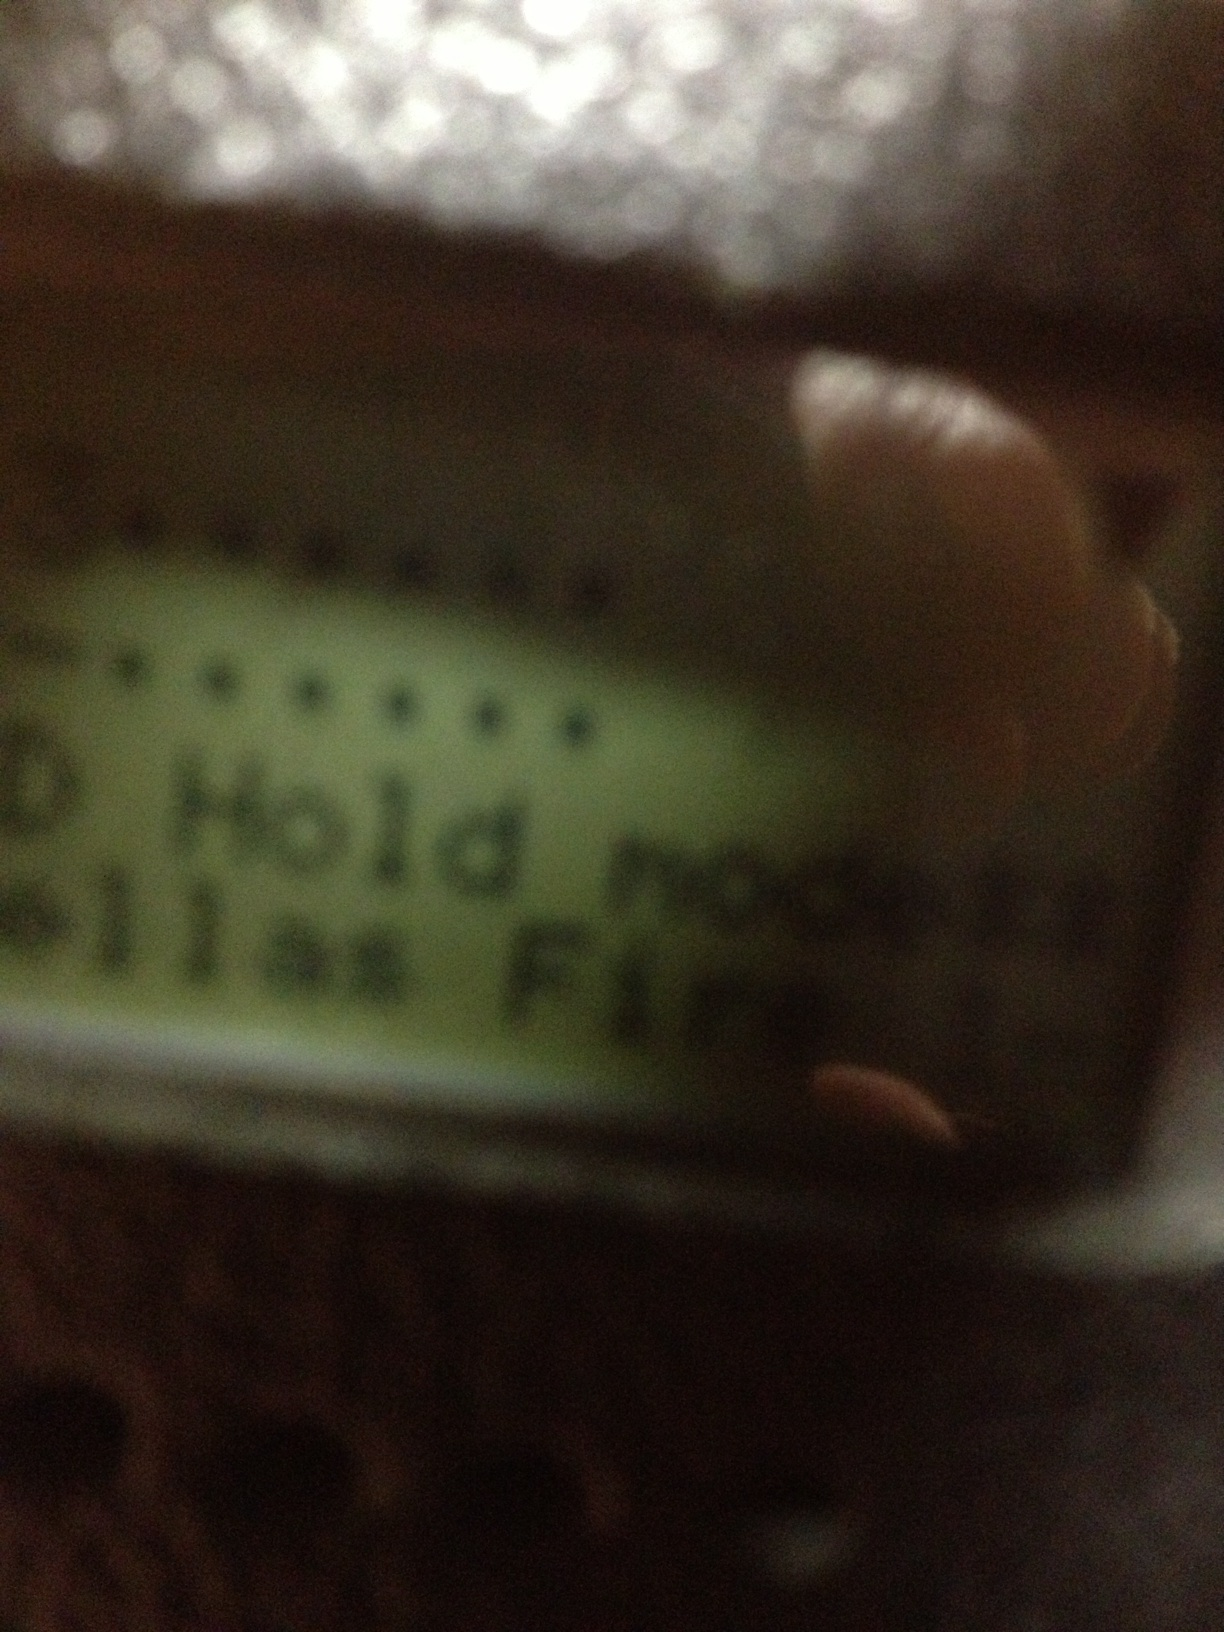Can you explain what 'Hold mode' might imply on this device? 'Hold mode' typically means that the device is in a paused state, where certain actions are temporarily halted. It could be similar to putting a call on hold or pausing a process. What other features might this device have? Based on the display, the device could have features like setting different modes or configurations, notifications or alerts (such as 'Bellas Fire'), and possibly options for adjustments. Devices with this type of screen are often used for specific controls in systems like communication tools, alert devices, or specialized settings. Could this image be part of a safety device? Yes, it's quite possible that this image is part of a safety device. The 'Hold mode' indication could be a part of a larger system where ensuring the device's status is crucial, such as in fire alarms, security systems, or emergency communication devices. 